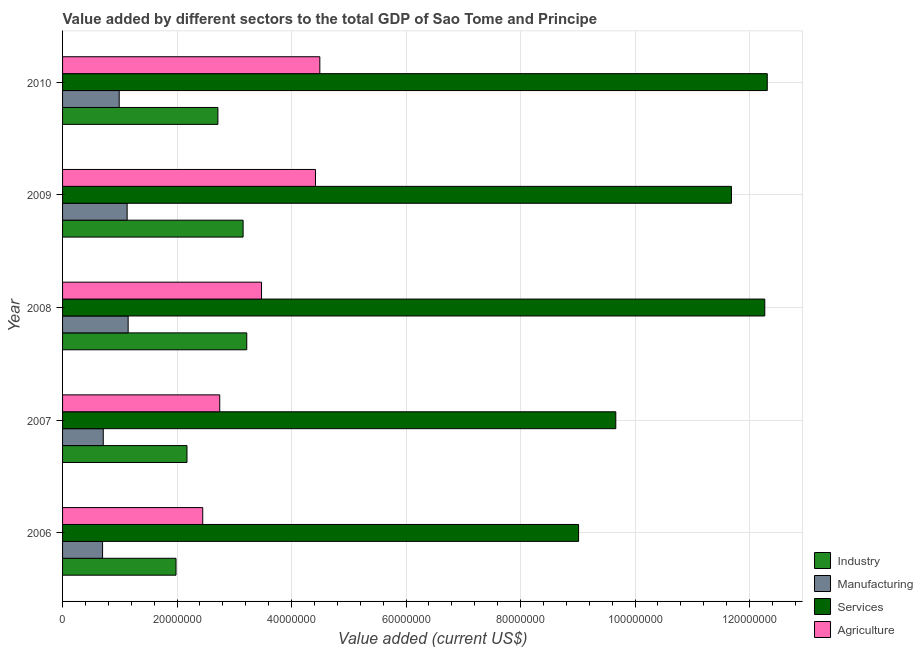Are the number of bars per tick equal to the number of legend labels?
Your answer should be very brief. Yes. Are the number of bars on each tick of the Y-axis equal?
Provide a short and direct response. Yes. How many bars are there on the 1st tick from the bottom?
Offer a very short reply. 4. What is the value added by industrial sector in 2009?
Your response must be concise. 3.15e+07. Across all years, what is the maximum value added by manufacturing sector?
Your answer should be very brief. 1.15e+07. Across all years, what is the minimum value added by services sector?
Provide a succinct answer. 9.01e+07. In which year was the value added by manufacturing sector maximum?
Offer a terse response. 2008. In which year was the value added by manufacturing sector minimum?
Make the answer very short. 2006. What is the total value added by manufacturing sector in the graph?
Offer a terse response. 4.67e+07. What is the difference between the value added by industrial sector in 2009 and that in 2010?
Give a very brief answer. 4.40e+06. What is the difference between the value added by manufacturing sector in 2007 and the value added by services sector in 2008?
Your answer should be very brief. -1.16e+08. What is the average value added by industrial sector per year?
Your answer should be very brief. 2.65e+07. In the year 2010, what is the difference between the value added by services sector and value added by manufacturing sector?
Offer a very short reply. 1.13e+08. In how many years, is the value added by manufacturing sector greater than 76000000 US$?
Keep it short and to the point. 0. What is the ratio of the value added by services sector in 2007 to that in 2010?
Your response must be concise. 0.79. What is the difference between the highest and the second highest value added by services sector?
Provide a succinct answer. 4.35e+05. What is the difference between the highest and the lowest value added by manufacturing sector?
Keep it short and to the point. 4.47e+06. Is the sum of the value added by agricultural sector in 2007 and 2008 greater than the maximum value added by manufacturing sector across all years?
Your answer should be very brief. Yes. Is it the case that in every year, the sum of the value added by agricultural sector and value added by manufacturing sector is greater than the sum of value added by services sector and value added by industrial sector?
Your answer should be compact. No. What does the 2nd bar from the top in 2008 represents?
Provide a succinct answer. Services. What does the 2nd bar from the bottom in 2009 represents?
Make the answer very short. Manufacturing. Is it the case that in every year, the sum of the value added by industrial sector and value added by manufacturing sector is greater than the value added by services sector?
Give a very brief answer. No. How many bars are there?
Keep it short and to the point. 20. What is the difference between two consecutive major ticks on the X-axis?
Provide a short and direct response. 2.00e+07. Are the values on the major ticks of X-axis written in scientific E-notation?
Your response must be concise. No. How are the legend labels stacked?
Your answer should be compact. Vertical. What is the title of the graph?
Your answer should be very brief. Value added by different sectors to the total GDP of Sao Tome and Principe. Does "Source data assessment" appear as one of the legend labels in the graph?
Provide a short and direct response. No. What is the label or title of the X-axis?
Ensure brevity in your answer.  Value added (current US$). What is the label or title of the Y-axis?
Ensure brevity in your answer.  Year. What is the Value added (current US$) in Industry in 2006?
Your response must be concise. 1.98e+07. What is the Value added (current US$) of Manufacturing in 2006?
Provide a succinct answer. 6.99e+06. What is the Value added (current US$) in Services in 2006?
Provide a short and direct response. 9.01e+07. What is the Value added (current US$) of Agriculture in 2006?
Give a very brief answer. 2.45e+07. What is the Value added (current US$) in Industry in 2007?
Keep it short and to the point. 2.17e+07. What is the Value added (current US$) in Manufacturing in 2007?
Keep it short and to the point. 7.11e+06. What is the Value added (current US$) in Services in 2007?
Offer a very short reply. 9.66e+07. What is the Value added (current US$) in Agriculture in 2007?
Provide a short and direct response. 2.75e+07. What is the Value added (current US$) of Industry in 2008?
Offer a terse response. 3.22e+07. What is the Value added (current US$) in Manufacturing in 2008?
Offer a very short reply. 1.15e+07. What is the Value added (current US$) in Services in 2008?
Keep it short and to the point. 1.23e+08. What is the Value added (current US$) in Agriculture in 2008?
Provide a short and direct response. 3.48e+07. What is the Value added (current US$) of Industry in 2009?
Provide a short and direct response. 3.15e+07. What is the Value added (current US$) in Manufacturing in 2009?
Give a very brief answer. 1.13e+07. What is the Value added (current US$) of Services in 2009?
Ensure brevity in your answer.  1.17e+08. What is the Value added (current US$) of Agriculture in 2009?
Keep it short and to the point. 4.42e+07. What is the Value added (current US$) in Industry in 2010?
Keep it short and to the point. 2.71e+07. What is the Value added (current US$) in Manufacturing in 2010?
Provide a short and direct response. 9.89e+06. What is the Value added (current US$) of Services in 2010?
Your response must be concise. 1.23e+08. What is the Value added (current US$) of Agriculture in 2010?
Offer a terse response. 4.49e+07. Across all years, what is the maximum Value added (current US$) of Industry?
Give a very brief answer. 3.22e+07. Across all years, what is the maximum Value added (current US$) of Manufacturing?
Offer a very short reply. 1.15e+07. Across all years, what is the maximum Value added (current US$) of Services?
Ensure brevity in your answer.  1.23e+08. Across all years, what is the maximum Value added (current US$) in Agriculture?
Your answer should be very brief. 4.49e+07. Across all years, what is the minimum Value added (current US$) of Industry?
Offer a terse response. 1.98e+07. Across all years, what is the minimum Value added (current US$) in Manufacturing?
Keep it short and to the point. 6.99e+06. Across all years, what is the minimum Value added (current US$) in Services?
Make the answer very short. 9.01e+07. Across all years, what is the minimum Value added (current US$) of Agriculture?
Give a very brief answer. 2.45e+07. What is the total Value added (current US$) in Industry in the graph?
Your response must be concise. 1.32e+08. What is the total Value added (current US$) of Manufacturing in the graph?
Keep it short and to the point. 4.67e+07. What is the total Value added (current US$) in Services in the graph?
Offer a terse response. 5.49e+08. What is the total Value added (current US$) of Agriculture in the graph?
Offer a terse response. 1.76e+08. What is the difference between the Value added (current US$) of Industry in 2006 and that in 2007?
Give a very brief answer. -1.92e+06. What is the difference between the Value added (current US$) of Manufacturing in 2006 and that in 2007?
Provide a short and direct response. -1.21e+05. What is the difference between the Value added (current US$) in Services in 2006 and that in 2007?
Give a very brief answer. -6.50e+06. What is the difference between the Value added (current US$) of Agriculture in 2006 and that in 2007?
Offer a very short reply. -2.97e+06. What is the difference between the Value added (current US$) in Industry in 2006 and that in 2008?
Offer a very short reply. -1.24e+07. What is the difference between the Value added (current US$) in Manufacturing in 2006 and that in 2008?
Give a very brief answer. -4.47e+06. What is the difference between the Value added (current US$) of Services in 2006 and that in 2008?
Your answer should be very brief. -3.25e+07. What is the difference between the Value added (current US$) of Agriculture in 2006 and that in 2008?
Offer a very short reply. -1.03e+07. What is the difference between the Value added (current US$) in Industry in 2006 and that in 2009?
Provide a succinct answer. -1.17e+07. What is the difference between the Value added (current US$) of Manufacturing in 2006 and that in 2009?
Provide a short and direct response. -4.29e+06. What is the difference between the Value added (current US$) of Services in 2006 and that in 2009?
Offer a terse response. -2.67e+07. What is the difference between the Value added (current US$) in Agriculture in 2006 and that in 2009?
Your answer should be very brief. -1.97e+07. What is the difference between the Value added (current US$) in Industry in 2006 and that in 2010?
Keep it short and to the point. -7.32e+06. What is the difference between the Value added (current US$) in Manufacturing in 2006 and that in 2010?
Keep it short and to the point. -2.91e+06. What is the difference between the Value added (current US$) of Services in 2006 and that in 2010?
Offer a very short reply. -3.30e+07. What is the difference between the Value added (current US$) in Agriculture in 2006 and that in 2010?
Your response must be concise. -2.05e+07. What is the difference between the Value added (current US$) of Industry in 2007 and that in 2008?
Your response must be concise. -1.04e+07. What is the difference between the Value added (current US$) in Manufacturing in 2007 and that in 2008?
Ensure brevity in your answer.  -4.35e+06. What is the difference between the Value added (current US$) of Services in 2007 and that in 2008?
Your answer should be very brief. -2.60e+07. What is the difference between the Value added (current US$) in Agriculture in 2007 and that in 2008?
Your answer should be very brief. -7.30e+06. What is the difference between the Value added (current US$) in Industry in 2007 and that in 2009?
Ensure brevity in your answer.  -9.80e+06. What is the difference between the Value added (current US$) of Manufacturing in 2007 and that in 2009?
Your answer should be compact. -4.17e+06. What is the difference between the Value added (current US$) of Services in 2007 and that in 2009?
Give a very brief answer. -2.02e+07. What is the difference between the Value added (current US$) of Agriculture in 2007 and that in 2009?
Keep it short and to the point. -1.67e+07. What is the difference between the Value added (current US$) of Industry in 2007 and that in 2010?
Your answer should be compact. -5.40e+06. What is the difference between the Value added (current US$) in Manufacturing in 2007 and that in 2010?
Keep it short and to the point. -2.78e+06. What is the difference between the Value added (current US$) of Services in 2007 and that in 2010?
Ensure brevity in your answer.  -2.65e+07. What is the difference between the Value added (current US$) in Agriculture in 2007 and that in 2010?
Provide a succinct answer. -1.75e+07. What is the difference between the Value added (current US$) of Industry in 2008 and that in 2009?
Offer a terse response. 6.39e+05. What is the difference between the Value added (current US$) of Manufacturing in 2008 and that in 2009?
Give a very brief answer. 1.76e+05. What is the difference between the Value added (current US$) in Services in 2008 and that in 2009?
Give a very brief answer. 5.82e+06. What is the difference between the Value added (current US$) in Agriculture in 2008 and that in 2009?
Give a very brief answer. -9.43e+06. What is the difference between the Value added (current US$) of Industry in 2008 and that in 2010?
Your answer should be compact. 5.04e+06. What is the difference between the Value added (current US$) of Manufacturing in 2008 and that in 2010?
Your answer should be compact. 1.56e+06. What is the difference between the Value added (current US$) in Services in 2008 and that in 2010?
Offer a terse response. -4.35e+05. What is the difference between the Value added (current US$) of Agriculture in 2008 and that in 2010?
Provide a short and direct response. -1.02e+07. What is the difference between the Value added (current US$) of Industry in 2009 and that in 2010?
Offer a terse response. 4.40e+06. What is the difference between the Value added (current US$) in Manufacturing in 2009 and that in 2010?
Your response must be concise. 1.39e+06. What is the difference between the Value added (current US$) of Services in 2009 and that in 2010?
Provide a succinct answer. -6.26e+06. What is the difference between the Value added (current US$) of Agriculture in 2009 and that in 2010?
Your answer should be very brief. -7.61e+05. What is the difference between the Value added (current US$) of Industry in 2006 and the Value added (current US$) of Manufacturing in 2007?
Provide a short and direct response. 1.27e+07. What is the difference between the Value added (current US$) of Industry in 2006 and the Value added (current US$) of Services in 2007?
Make the answer very short. -7.68e+07. What is the difference between the Value added (current US$) of Industry in 2006 and the Value added (current US$) of Agriculture in 2007?
Ensure brevity in your answer.  -7.64e+06. What is the difference between the Value added (current US$) in Manufacturing in 2006 and the Value added (current US$) in Services in 2007?
Your answer should be compact. -8.97e+07. What is the difference between the Value added (current US$) in Manufacturing in 2006 and the Value added (current US$) in Agriculture in 2007?
Keep it short and to the point. -2.05e+07. What is the difference between the Value added (current US$) in Services in 2006 and the Value added (current US$) in Agriculture in 2007?
Your response must be concise. 6.27e+07. What is the difference between the Value added (current US$) of Industry in 2006 and the Value added (current US$) of Manufacturing in 2008?
Your answer should be very brief. 8.36e+06. What is the difference between the Value added (current US$) in Industry in 2006 and the Value added (current US$) in Services in 2008?
Offer a very short reply. -1.03e+08. What is the difference between the Value added (current US$) of Industry in 2006 and the Value added (current US$) of Agriculture in 2008?
Offer a very short reply. -1.49e+07. What is the difference between the Value added (current US$) of Manufacturing in 2006 and the Value added (current US$) of Services in 2008?
Offer a very short reply. -1.16e+08. What is the difference between the Value added (current US$) in Manufacturing in 2006 and the Value added (current US$) in Agriculture in 2008?
Give a very brief answer. -2.78e+07. What is the difference between the Value added (current US$) in Services in 2006 and the Value added (current US$) in Agriculture in 2008?
Provide a short and direct response. 5.54e+07. What is the difference between the Value added (current US$) of Industry in 2006 and the Value added (current US$) of Manufacturing in 2009?
Offer a terse response. 8.54e+06. What is the difference between the Value added (current US$) in Industry in 2006 and the Value added (current US$) in Services in 2009?
Make the answer very short. -9.70e+07. What is the difference between the Value added (current US$) of Industry in 2006 and the Value added (current US$) of Agriculture in 2009?
Your response must be concise. -2.44e+07. What is the difference between the Value added (current US$) of Manufacturing in 2006 and the Value added (current US$) of Services in 2009?
Give a very brief answer. -1.10e+08. What is the difference between the Value added (current US$) of Manufacturing in 2006 and the Value added (current US$) of Agriculture in 2009?
Keep it short and to the point. -3.72e+07. What is the difference between the Value added (current US$) in Services in 2006 and the Value added (current US$) in Agriculture in 2009?
Offer a terse response. 4.60e+07. What is the difference between the Value added (current US$) of Industry in 2006 and the Value added (current US$) of Manufacturing in 2010?
Give a very brief answer. 9.92e+06. What is the difference between the Value added (current US$) in Industry in 2006 and the Value added (current US$) in Services in 2010?
Offer a very short reply. -1.03e+08. What is the difference between the Value added (current US$) in Industry in 2006 and the Value added (current US$) in Agriculture in 2010?
Give a very brief answer. -2.51e+07. What is the difference between the Value added (current US$) of Manufacturing in 2006 and the Value added (current US$) of Services in 2010?
Your answer should be very brief. -1.16e+08. What is the difference between the Value added (current US$) of Manufacturing in 2006 and the Value added (current US$) of Agriculture in 2010?
Provide a succinct answer. -3.80e+07. What is the difference between the Value added (current US$) in Services in 2006 and the Value added (current US$) in Agriculture in 2010?
Your answer should be very brief. 4.52e+07. What is the difference between the Value added (current US$) of Industry in 2007 and the Value added (current US$) of Manufacturing in 2008?
Ensure brevity in your answer.  1.03e+07. What is the difference between the Value added (current US$) of Industry in 2007 and the Value added (current US$) of Services in 2008?
Your response must be concise. -1.01e+08. What is the difference between the Value added (current US$) of Industry in 2007 and the Value added (current US$) of Agriculture in 2008?
Ensure brevity in your answer.  -1.30e+07. What is the difference between the Value added (current US$) in Manufacturing in 2007 and the Value added (current US$) in Services in 2008?
Offer a very short reply. -1.16e+08. What is the difference between the Value added (current US$) in Manufacturing in 2007 and the Value added (current US$) in Agriculture in 2008?
Your answer should be very brief. -2.76e+07. What is the difference between the Value added (current US$) in Services in 2007 and the Value added (current US$) in Agriculture in 2008?
Provide a succinct answer. 6.19e+07. What is the difference between the Value added (current US$) in Industry in 2007 and the Value added (current US$) in Manufacturing in 2009?
Give a very brief answer. 1.05e+07. What is the difference between the Value added (current US$) of Industry in 2007 and the Value added (current US$) of Services in 2009?
Your answer should be very brief. -9.51e+07. What is the difference between the Value added (current US$) in Industry in 2007 and the Value added (current US$) in Agriculture in 2009?
Ensure brevity in your answer.  -2.24e+07. What is the difference between the Value added (current US$) in Manufacturing in 2007 and the Value added (current US$) in Services in 2009?
Offer a terse response. -1.10e+08. What is the difference between the Value added (current US$) of Manufacturing in 2007 and the Value added (current US$) of Agriculture in 2009?
Ensure brevity in your answer.  -3.71e+07. What is the difference between the Value added (current US$) in Services in 2007 and the Value added (current US$) in Agriculture in 2009?
Offer a terse response. 5.25e+07. What is the difference between the Value added (current US$) of Industry in 2007 and the Value added (current US$) of Manufacturing in 2010?
Ensure brevity in your answer.  1.18e+07. What is the difference between the Value added (current US$) of Industry in 2007 and the Value added (current US$) of Services in 2010?
Offer a very short reply. -1.01e+08. What is the difference between the Value added (current US$) of Industry in 2007 and the Value added (current US$) of Agriculture in 2010?
Keep it short and to the point. -2.32e+07. What is the difference between the Value added (current US$) of Manufacturing in 2007 and the Value added (current US$) of Services in 2010?
Give a very brief answer. -1.16e+08. What is the difference between the Value added (current US$) in Manufacturing in 2007 and the Value added (current US$) in Agriculture in 2010?
Your answer should be very brief. -3.78e+07. What is the difference between the Value added (current US$) in Services in 2007 and the Value added (current US$) in Agriculture in 2010?
Offer a very short reply. 5.17e+07. What is the difference between the Value added (current US$) in Industry in 2008 and the Value added (current US$) in Manufacturing in 2009?
Your response must be concise. 2.09e+07. What is the difference between the Value added (current US$) in Industry in 2008 and the Value added (current US$) in Services in 2009?
Make the answer very short. -8.47e+07. What is the difference between the Value added (current US$) in Industry in 2008 and the Value added (current US$) in Agriculture in 2009?
Your response must be concise. -1.20e+07. What is the difference between the Value added (current US$) in Manufacturing in 2008 and the Value added (current US$) in Services in 2009?
Keep it short and to the point. -1.05e+08. What is the difference between the Value added (current US$) of Manufacturing in 2008 and the Value added (current US$) of Agriculture in 2009?
Offer a very short reply. -3.27e+07. What is the difference between the Value added (current US$) in Services in 2008 and the Value added (current US$) in Agriculture in 2009?
Provide a succinct answer. 7.85e+07. What is the difference between the Value added (current US$) of Industry in 2008 and the Value added (current US$) of Manufacturing in 2010?
Make the answer very short. 2.23e+07. What is the difference between the Value added (current US$) in Industry in 2008 and the Value added (current US$) in Services in 2010?
Provide a short and direct response. -9.09e+07. What is the difference between the Value added (current US$) of Industry in 2008 and the Value added (current US$) of Agriculture in 2010?
Give a very brief answer. -1.28e+07. What is the difference between the Value added (current US$) of Manufacturing in 2008 and the Value added (current US$) of Services in 2010?
Offer a very short reply. -1.12e+08. What is the difference between the Value added (current US$) in Manufacturing in 2008 and the Value added (current US$) in Agriculture in 2010?
Provide a short and direct response. -3.35e+07. What is the difference between the Value added (current US$) in Services in 2008 and the Value added (current US$) in Agriculture in 2010?
Offer a terse response. 7.77e+07. What is the difference between the Value added (current US$) in Industry in 2009 and the Value added (current US$) in Manufacturing in 2010?
Give a very brief answer. 2.16e+07. What is the difference between the Value added (current US$) in Industry in 2009 and the Value added (current US$) in Services in 2010?
Provide a succinct answer. -9.16e+07. What is the difference between the Value added (current US$) of Industry in 2009 and the Value added (current US$) of Agriculture in 2010?
Ensure brevity in your answer.  -1.34e+07. What is the difference between the Value added (current US$) of Manufacturing in 2009 and the Value added (current US$) of Services in 2010?
Offer a terse response. -1.12e+08. What is the difference between the Value added (current US$) in Manufacturing in 2009 and the Value added (current US$) in Agriculture in 2010?
Your response must be concise. -3.37e+07. What is the difference between the Value added (current US$) of Services in 2009 and the Value added (current US$) of Agriculture in 2010?
Offer a terse response. 7.19e+07. What is the average Value added (current US$) in Industry per year?
Offer a very short reply. 2.65e+07. What is the average Value added (current US$) in Manufacturing per year?
Keep it short and to the point. 9.35e+06. What is the average Value added (current US$) of Services per year?
Make the answer very short. 1.10e+08. What is the average Value added (current US$) of Agriculture per year?
Offer a very short reply. 3.52e+07. In the year 2006, what is the difference between the Value added (current US$) in Industry and Value added (current US$) in Manufacturing?
Offer a terse response. 1.28e+07. In the year 2006, what is the difference between the Value added (current US$) of Industry and Value added (current US$) of Services?
Your answer should be very brief. -7.03e+07. In the year 2006, what is the difference between the Value added (current US$) of Industry and Value added (current US$) of Agriculture?
Keep it short and to the point. -4.67e+06. In the year 2006, what is the difference between the Value added (current US$) in Manufacturing and Value added (current US$) in Services?
Offer a terse response. -8.32e+07. In the year 2006, what is the difference between the Value added (current US$) of Manufacturing and Value added (current US$) of Agriculture?
Offer a terse response. -1.75e+07. In the year 2006, what is the difference between the Value added (current US$) in Services and Value added (current US$) in Agriculture?
Provide a succinct answer. 6.57e+07. In the year 2007, what is the difference between the Value added (current US$) of Industry and Value added (current US$) of Manufacturing?
Give a very brief answer. 1.46e+07. In the year 2007, what is the difference between the Value added (current US$) in Industry and Value added (current US$) in Services?
Ensure brevity in your answer.  -7.49e+07. In the year 2007, what is the difference between the Value added (current US$) of Industry and Value added (current US$) of Agriculture?
Provide a succinct answer. -5.72e+06. In the year 2007, what is the difference between the Value added (current US$) in Manufacturing and Value added (current US$) in Services?
Ensure brevity in your answer.  -8.95e+07. In the year 2007, what is the difference between the Value added (current US$) of Manufacturing and Value added (current US$) of Agriculture?
Give a very brief answer. -2.03e+07. In the year 2007, what is the difference between the Value added (current US$) of Services and Value added (current US$) of Agriculture?
Offer a very short reply. 6.92e+07. In the year 2008, what is the difference between the Value added (current US$) in Industry and Value added (current US$) in Manufacturing?
Make the answer very short. 2.07e+07. In the year 2008, what is the difference between the Value added (current US$) in Industry and Value added (current US$) in Services?
Your answer should be compact. -9.05e+07. In the year 2008, what is the difference between the Value added (current US$) of Industry and Value added (current US$) of Agriculture?
Ensure brevity in your answer.  -2.58e+06. In the year 2008, what is the difference between the Value added (current US$) of Manufacturing and Value added (current US$) of Services?
Provide a short and direct response. -1.11e+08. In the year 2008, what is the difference between the Value added (current US$) of Manufacturing and Value added (current US$) of Agriculture?
Offer a terse response. -2.33e+07. In the year 2008, what is the difference between the Value added (current US$) in Services and Value added (current US$) in Agriculture?
Provide a short and direct response. 8.79e+07. In the year 2009, what is the difference between the Value added (current US$) of Industry and Value added (current US$) of Manufacturing?
Ensure brevity in your answer.  2.03e+07. In the year 2009, what is the difference between the Value added (current US$) in Industry and Value added (current US$) in Services?
Your response must be concise. -8.53e+07. In the year 2009, what is the difference between the Value added (current US$) in Industry and Value added (current US$) in Agriculture?
Provide a succinct answer. -1.26e+07. In the year 2009, what is the difference between the Value added (current US$) of Manufacturing and Value added (current US$) of Services?
Provide a succinct answer. -1.06e+08. In the year 2009, what is the difference between the Value added (current US$) in Manufacturing and Value added (current US$) in Agriculture?
Make the answer very short. -3.29e+07. In the year 2009, what is the difference between the Value added (current US$) in Services and Value added (current US$) in Agriculture?
Offer a terse response. 7.27e+07. In the year 2010, what is the difference between the Value added (current US$) of Industry and Value added (current US$) of Manufacturing?
Provide a short and direct response. 1.72e+07. In the year 2010, what is the difference between the Value added (current US$) in Industry and Value added (current US$) in Services?
Your response must be concise. -9.60e+07. In the year 2010, what is the difference between the Value added (current US$) of Industry and Value added (current US$) of Agriculture?
Give a very brief answer. -1.78e+07. In the year 2010, what is the difference between the Value added (current US$) in Manufacturing and Value added (current US$) in Services?
Make the answer very short. -1.13e+08. In the year 2010, what is the difference between the Value added (current US$) in Manufacturing and Value added (current US$) in Agriculture?
Keep it short and to the point. -3.50e+07. In the year 2010, what is the difference between the Value added (current US$) in Services and Value added (current US$) in Agriculture?
Your answer should be very brief. 7.82e+07. What is the ratio of the Value added (current US$) in Industry in 2006 to that in 2007?
Provide a short and direct response. 0.91. What is the ratio of the Value added (current US$) in Manufacturing in 2006 to that in 2007?
Your answer should be compact. 0.98. What is the ratio of the Value added (current US$) of Services in 2006 to that in 2007?
Ensure brevity in your answer.  0.93. What is the ratio of the Value added (current US$) in Agriculture in 2006 to that in 2007?
Provide a short and direct response. 0.89. What is the ratio of the Value added (current US$) of Industry in 2006 to that in 2008?
Offer a very short reply. 0.62. What is the ratio of the Value added (current US$) of Manufacturing in 2006 to that in 2008?
Your answer should be compact. 0.61. What is the ratio of the Value added (current US$) in Services in 2006 to that in 2008?
Your answer should be compact. 0.73. What is the ratio of the Value added (current US$) of Agriculture in 2006 to that in 2008?
Keep it short and to the point. 0.7. What is the ratio of the Value added (current US$) in Industry in 2006 to that in 2009?
Make the answer very short. 0.63. What is the ratio of the Value added (current US$) of Manufacturing in 2006 to that in 2009?
Provide a short and direct response. 0.62. What is the ratio of the Value added (current US$) of Services in 2006 to that in 2009?
Ensure brevity in your answer.  0.77. What is the ratio of the Value added (current US$) of Agriculture in 2006 to that in 2009?
Provide a succinct answer. 0.55. What is the ratio of the Value added (current US$) of Industry in 2006 to that in 2010?
Keep it short and to the point. 0.73. What is the ratio of the Value added (current US$) in Manufacturing in 2006 to that in 2010?
Offer a very short reply. 0.71. What is the ratio of the Value added (current US$) of Services in 2006 to that in 2010?
Provide a short and direct response. 0.73. What is the ratio of the Value added (current US$) in Agriculture in 2006 to that in 2010?
Offer a very short reply. 0.54. What is the ratio of the Value added (current US$) of Industry in 2007 to that in 2008?
Make the answer very short. 0.68. What is the ratio of the Value added (current US$) in Manufacturing in 2007 to that in 2008?
Your answer should be compact. 0.62. What is the ratio of the Value added (current US$) in Services in 2007 to that in 2008?
Your answer should be compact. 0.79. What is the ratio of the Value added (current US$) of Agriculture in 2007 to that in 2008?
Provide a short and direct response. 0.79. What is the ratio of the Value added (current US$) in Industry in 2007 to that in 2009?
Make the answer very short. 0.69. What is the ratio of the Value added (current US$) of Manufacturing in 2007 to that in 2009?
Your answer should be very brief. 0.63. What is the ratio of the Value added (current US$) of Services in 2007 to that in 2009?
Your answer should be compact. 0.83. What is the ratio of the Value added (current US$) in Agriculture in 2007 to that in 2009?
Your answer should be very brief. 0.62. What is the ratio of the Value added (current US$) of Industry in 2007 to that in 2010?
Keep it short and to the point. 0.8. What is the ratio of the Value added (current US$) of Manufacturing in 2007 to that in 2010?
Offer a terse response. 0.72. What is the ratio of the Value added (current US$) in Services in 2007 to that in 2010?
Provide a short and direct response. 0.79. What is the ratio of the Value added (current US$) of Agriculture in 2007 to that in 2010?
Your answer should be very brief. 0.61. What is the ratio of the Value added (current US$) in Industry in 2008 to that in 2009?
Your response must be concise. 1.02. What is the ratio of the Value added (current US$) of Manufacturing in 2008 to that in 2009?
Make the answer very short. 1.02. What is the ratio of the Value added (current US$) in Services in 2008 to that in 2009?
Offer a very short reply. 1.05. What is the ratio of the Value added (current US$) in Agriculture in 2008 to that in 2009?
Offer a very short reply. 0.79. What is the ratio of the Value added (current US$) of Industry in 2008 to that in 2010?
Make the answer very short. 1.19. What is the ratio of the Value added (current US$) in Manufacturing in 2008 to that in 2010?
Keep it short and to the point. 1.16. What is the ratio of the Value added (current US$) of Services in 2008 to that in 2010?
Provide a short and direct response. 1. What is the ratio of the Value added (current US$) of Agriculture in 2008 to that in 2010?
Offer a terse response. 0.77. What is the ratio of the Value added (current US$) of Industry in 2009 to that in 2010?
Your response must be concise. 1.16. What is the ratio of the Value added (current US$) of Manufacturing in 2009 to that in 2010?
Your response must be concise. 1.14. What is the ratio of the Value added (current US$) in Services in 2009 to that in 2010?
Provide a short and direct response. 0.95. What is the ratio of the Value added (current US$) of Agriculture in 2009 to that in 2010?
Offer a very short reply. 0.98. What is the difference between the highest and the second highest Value added (current US$) in Industry?
Ensure brevity in your answer.  6.39e+05. What is the difference between the highest and the second highest Value added (current US$) of Manufacturing?
Give a very brief answer. 1.76e+05. What is the difference between the highest and the second highest Value added (current US$) in Services?
Provide a short and direct response. 4.35e+05. What is the difference between the highest and the second highest Value added (current US$) of Agriculture?
Your answer should be very brief. 7.61e+05. What is the difference between the highest and the lowest Value added (current US$) of Industry?
Ensure brevity in your answer.  1.24e+07. What is the difference between the highest and the lowest Value added (current US$) in Manufacturing?
Ensure brevity in your answer.  4.47e+06. What is the difference between the highest and the lowest Value added (current US$) in Services?
Your answer should be very brief. 3.30e+07. What is the difference between the highest and the lowest Value added (current US$) of Agriculture?
Keep it short and to the point. 2.05e+07. 